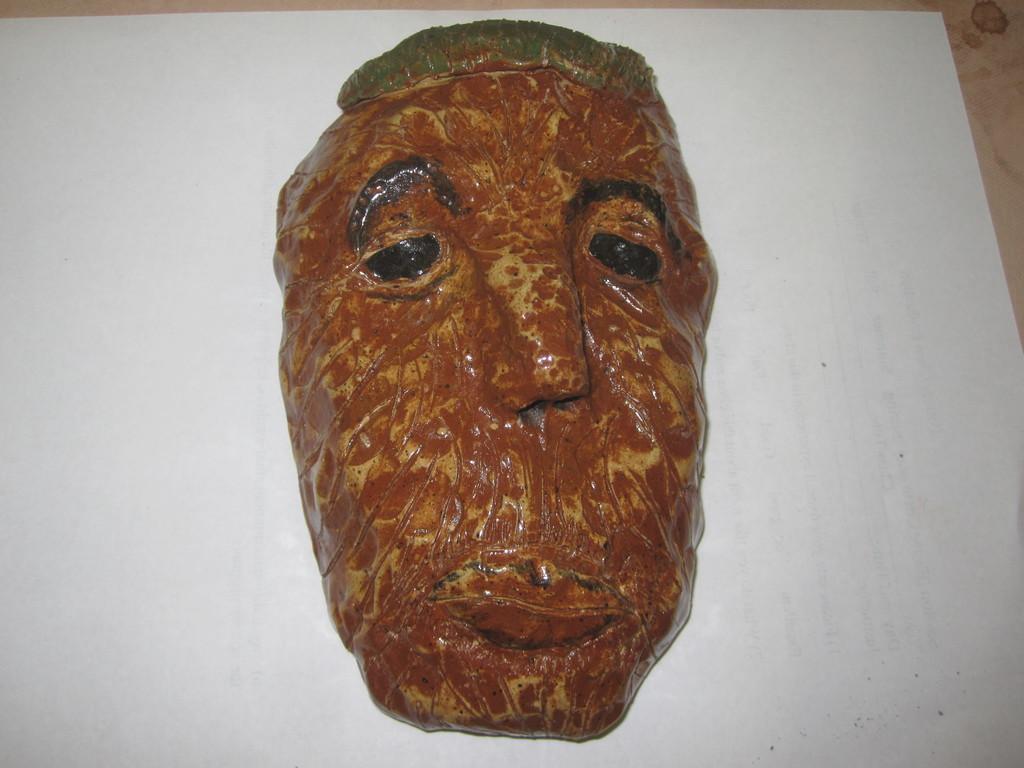How would you summarize this image in a sentence or two? In this image I can see a sculpture of a person's face on a white surface. 